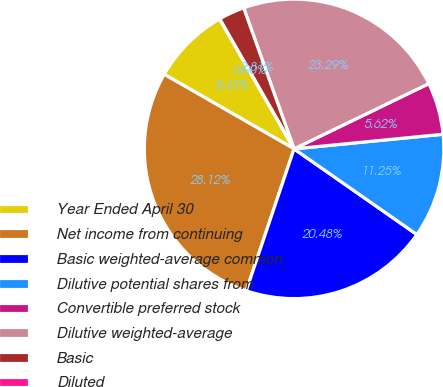<chart> <loc_0><loc_0><loc_500><loc_500><pie_chart><fcel>Year Ended April 30<fcel>Net income from continuing<fcel>Basic weighted-average common<fcel>Dilutive potential shares from<fcel>Convertible preferred stock<fcel>Dilutive weighted-average<fcel>Basic<fcel>Diluted<nl><fcel>8.43%<fcel>28.12%<fcel>20.48%<fcel>11.25%<fcel>5.62%<fcel>23.29%<fcel>2.81%<fcel>0.0%<nl></chart> 